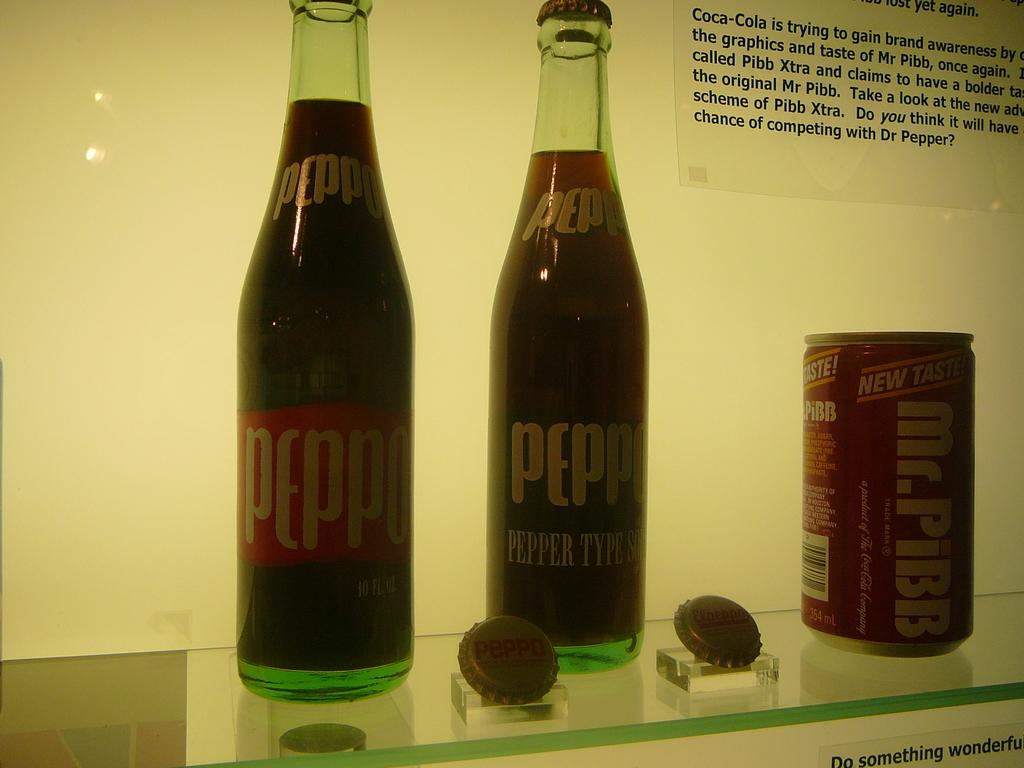Provide a one-sentence caption for the provided image. A display of old time sodas including a can of Mr. Pibb. 